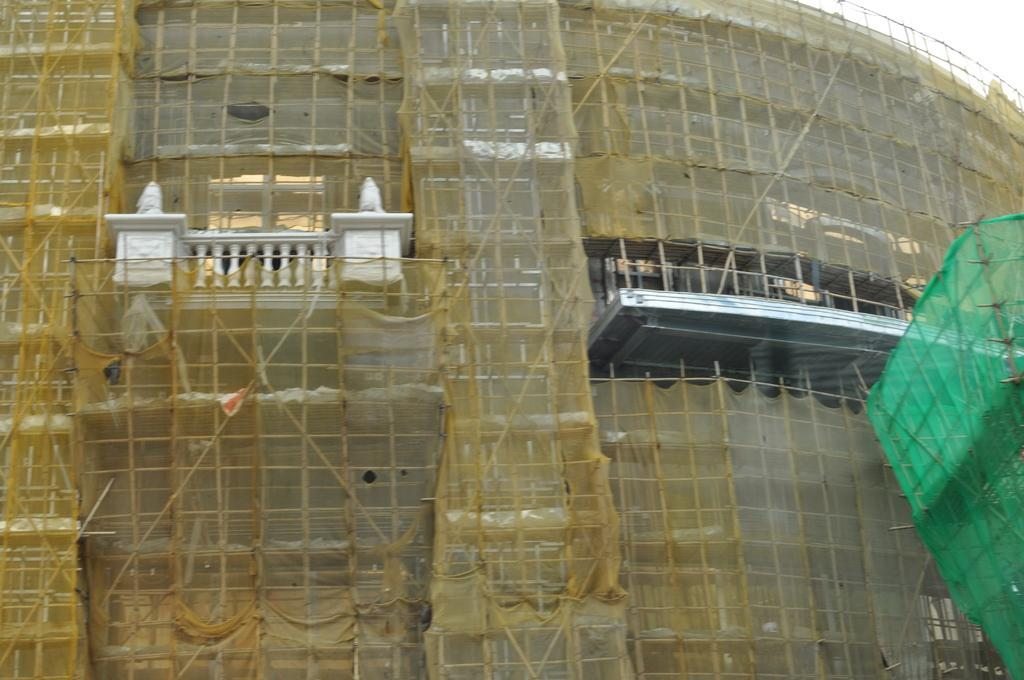What is the main subject of the image? The main subject of the image is a construction of a building. Can you describe the sky in the image? The sky is visible in the top right side of the image. What type of comfort can be seen in the image? There is no specific comfort depicted in the image, as it primarily features a construction site. 